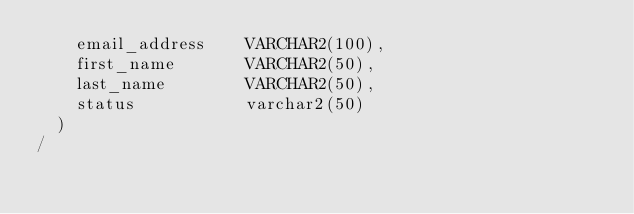<code> <loc_0><loc_0><loc_500><loc_500><_SQL_>    email_address    VARCHAR2(100),
    first_name       VARCHAR2(50),
    last_name        VARCHAR2(50),
    status           varchar2(50)
  )
/</code> 